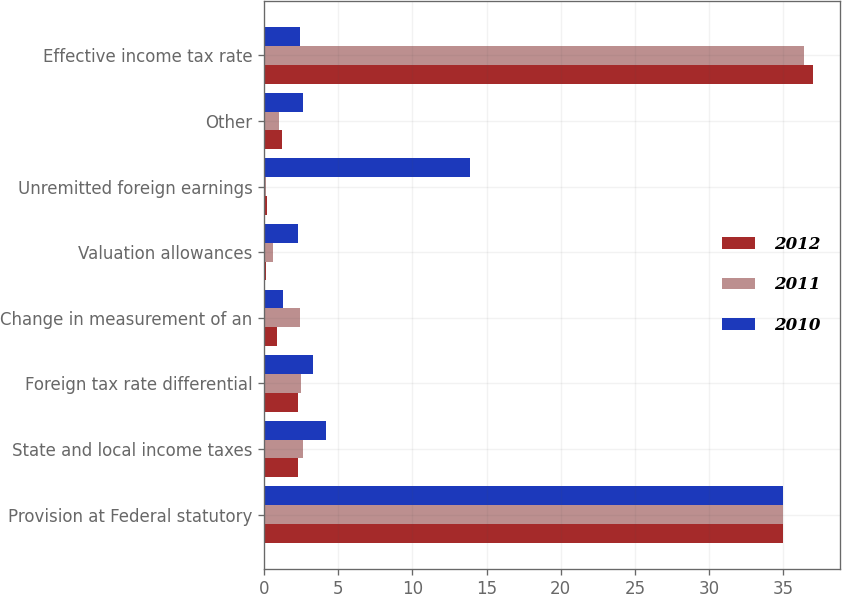<chart> <loc_0><loc_0><loc_500><loc_500><stacked_bar_chart><ecel><fcel>Provision at Federal statutory<fcel>State and local income taxes<fcel>Foreign tax rate differential<fcel>Change in measurement of an<fcel>Valuation allowances<fcel>Unremitted foreign earnings<fcel>Other<fcel>Effective income tax rate<nl><fcel>2012<fcel>35<fcel>2.3<fcel>2.3<fcel>0.9<fcel>0.1<fcel>0.2<fcel>1.2<fcel>37<nl><fcel>2011<fcel>35<fcel>2.6<fcel>2.5<fcel>2.4<fcel>0.6<fcel>0.1<fcel>1<fcel>36.4<nl><fcel>2010<fcel>35<fcel>4.2<fcel>3.3<fcel>1.3<fcel>2.3<fcel>13.9<fcel>2.6<fcel>2.4<nl></chart> 